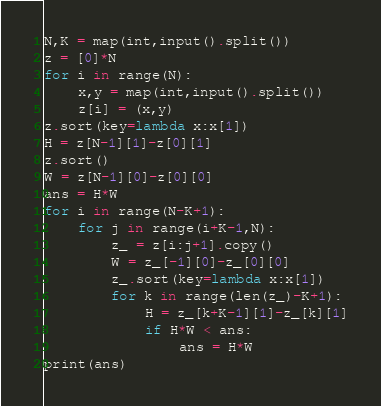Convert code to text. <code><loc_0><loc_0><loc_500><loc_500><_Python_>N,K = map(int,input().split())
z = [0]*N
for i in range(N):
    x,y = map(int,input().split())
    z[i] = (x,y)
z.sort(key=lambda x:x[1])
H = z[N-1][1]-z[0][1]
z.sort()
W = z[N-1][0]-z[0][0]
ans = H*W
for i in range(N-K+1):
    for j in range(i+K-1,N):
        z_ = z[i:j+1].copy()
        W = z_[-1][0]-z_[0][0]
        z_.sort(key=lambda x:x[1])
        for k in range(len(z_)-K+1):
            H = z_[k+K-1][1]-z_[k][1]
            if H*W < ans:
                ans = H*W
print(ans)</code> 